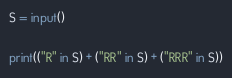Convert code to text. <code><loc_0><loc_0><loc_500><loc_500><_Python_>S = input()

print(("R" in S) + ("RR" in S) + ("RRR" in S))</code> 